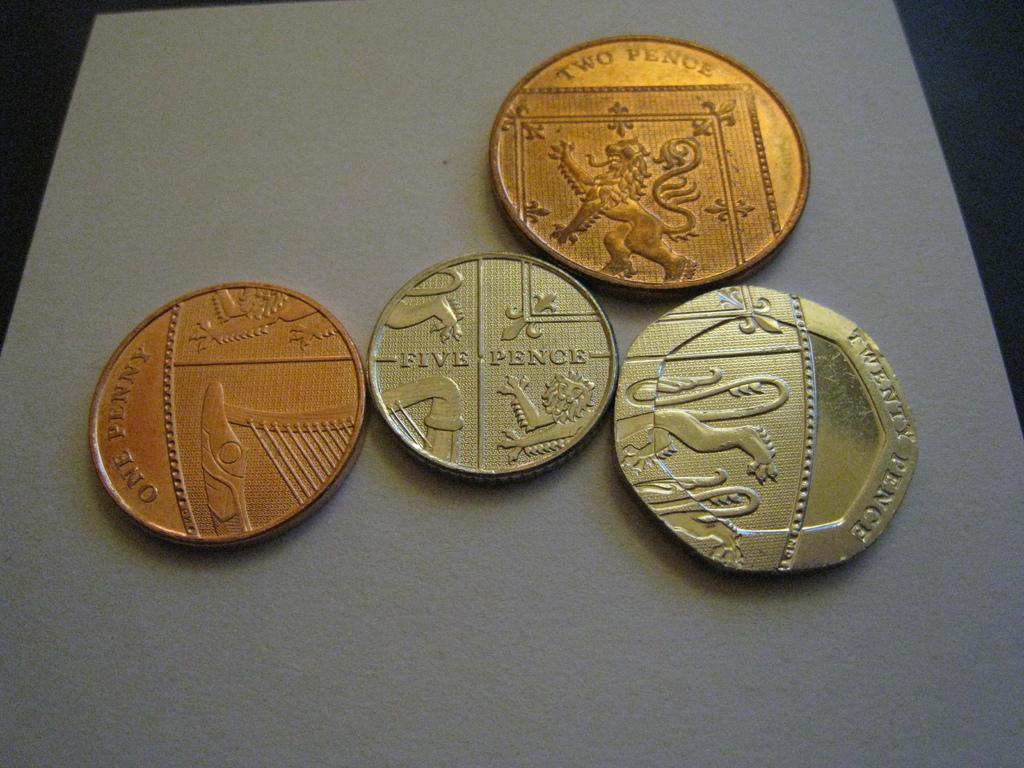Could you give a brief overview of what you see in this image? In this picture, we see the four currency coins are placed on the white table. Two of the coins are in dark gold color. 